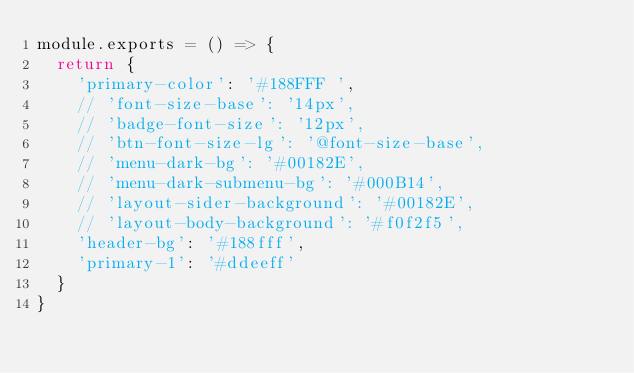Convert code to text. <code><loc_0><loc_0><loc_500><loc_500><_JavaScript_>module.exports = () => {
  return {
    'primary-color': '#188FFF ',
    // 'font-size-base': '14px',
    // 'badge-font-size': '12px',
    // 'btn-font-size-lg': '@font-size-base',
    // 'menu-dark-bg': '#00182E',
    // 'menu-dark-submenu-bg': '#000B14',
    // 'layout-sider-background': '#00182E',
    // 'layout-body-background': '#f0f2f5',
    'header-bg': '#188fff',
    'primary-1': '#ddeeff'
  }
}
</code> 